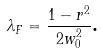<formula> <loc_0><loc_0><loc_500><loc_500>\lambda _ { F } = \frac { 1 - r ^ { 2 } } { 2 w _ { 0 } ^ { 2 } } \text {.}</formula> 